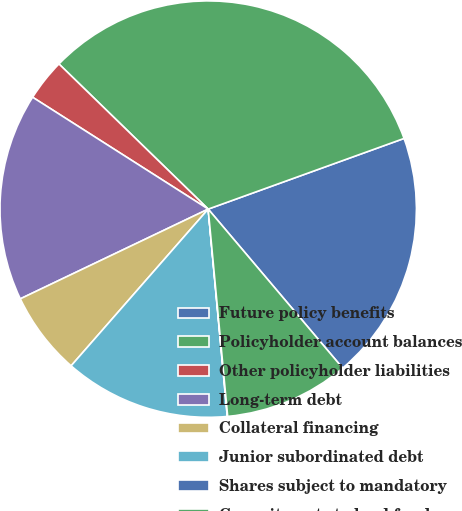Convert chart to OTSL. <chart><loc_0><loc_0><loc_500><loc_500><pie_chart><fcel>Future policy benefits<fcel>Policyholder account balances<fcel>Other policyholder liabilities<fcel>Long-term debt<fcel>Collateral financing<fcel>Junior subordinated debt<fcel>Shares subject to mandatory<fcel>Commitments to lend funds<nl><fcel>19.34%<fcel>32.21%<fcel>3.25%<fcel>16.12%<fcel>6.47%<fcel>12.9%<fcel>0.03%<fcel>9.68%<nl></chart> 